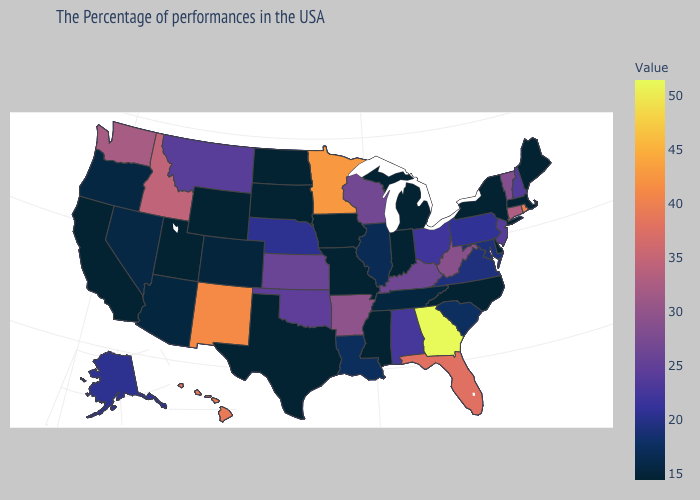Which states hav the highest value in the MidWest?
Write a very short answer. Minnesota. Which states hav the highest value in the Northeast?
Short answer required. Rhode Island. Which states hav the highest value in the MidWest?
Quick response, please. Minnesota. Among the states that border Nebraska , which have the lowest value?
Answer briefly. Missouri, Iowa, South Dakota, Wyoming. Does the map have missing data?
Write a very short answer. No. Is the legend a continuous bar?
Write a very short answer. Yes. 